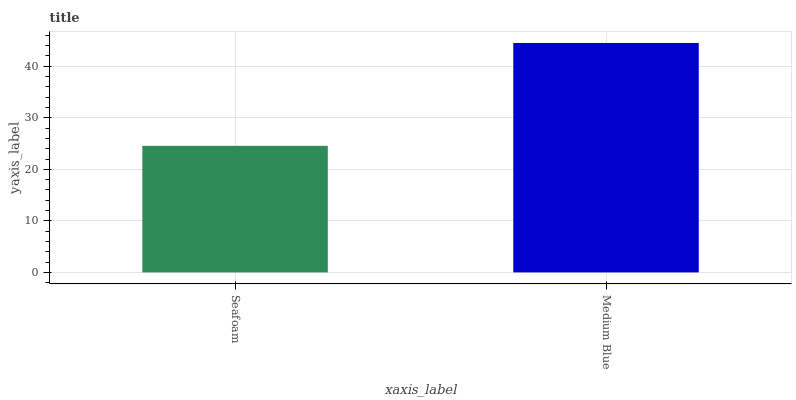Is Medium Blue the minimum?
Answer yes or no. No. Is Medium Blue greater than Seafoam?
Answer yes or no. Yes. Is Seafoam less than Medium Blue?
Answer yes or no. Yes. Is Seafoam greater than Medium Blue?
Answer yes or no. No. Is Medium Blue less than Seafoam?
Answer yes or no. No. Is Medium Blue the high median?
Answer yes or no. Yes. Is Seafoam the low median?
Answer yes or no. Yes. Is Seafoam the high median?
Answer yes or no. No. Is Medium Blue the low median?
Answer yes or no. No. 